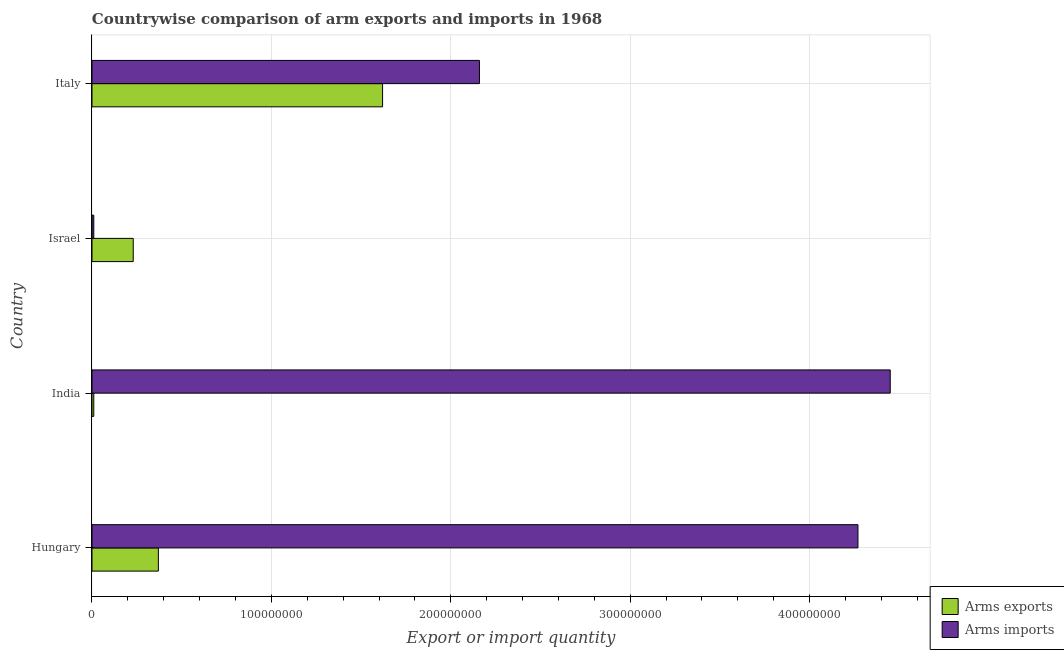How many different coloured bars are there?
Offer a very short reply. 2. How many groups of bars are there?
Offer a terse response. 4. How many bars are there on the 1st tick from the top?
Provide a short and direct response. 2. How many bars are there on the 1st tick from the bottom?
Provide a short and direct response. 2. What is the arms imports in Israel?
Your answer should be very brief. 1.00e+06. Across all countries, what is the maximum arms imports?
Provide a succinct answer. 4.45e+08. Across all countries, what is the minimum arms imports?
Give a very brief answer. 1.00e+06. In which country was the arms exports minimum?
Ensure brevity in your answer.  India. What is the total arms exports in the graph?
Offer a terse response. 2.23e+08. What is the difference between the arms imports in India and that in Italy?
Your answer should be compact. 2.29e+08. What is the difference between the arms exports in Israel and the arms imports in Italy?
Offer a terse response. -1.93e+08. What is the average arms imports per country?
Offer a very short reply. 2.72e+08. What is the difference between the arms exports and arms imports in India?
Your answer should be very brief. -4.44e+08. In how many countries, is the arms exports greater than 300000000 ?
Your response must be concise. 0. What is the ratio of the arms exports in Hungary to that in Italy?
Keep it short and to the point. 0.23. Is the arms exports in India less than that in Israel?
Offer a terse response. Yes. Is the difference between the arms exports in Israel and Italy greater than the difference between the arms imports in Israel and Italy?
Ensure brevity in your answer.  Yes. What is the difference between the highest and the second highest arms imports?
Your answer should be very brief. 1.80e+07. What is the difference between the highest and the lowest arms exports?
Ensure brevity in your answer.  1.61e+08. In how many countries, is the arms imports greater than the average arms imports taken over all countries?
Your answer should be very brief. 2. Is the sum of the arms exports in India and Italy greater than the maximum arms imports across all countries?
Keep it short and to the point. No. What does the 1st bar from the top in Israel represents?
Offer a terse response. Arms imports. What does the 2nd bar from the bottom in Italy represents?
Offer a very short reply. Arms imports. Are all the bars in the graph horizontal?
Your response must be concise. Yes. How many countries are there in the graph?
Your answer should be compact. 4. What is the difference between two consecutive major ticks on the X-axis?
Give a very brief answer. 1.00e+08. Are the values on the major ticks of X-axis written in scientific E-notation?
Provide a succinct answer. No. How many legend labels are there?
Ensure brevity in your answer.  2. What is the title of the graph?
Offer a terse response. Countrywise comparison of arm exports and imports in 1968. Does "Female entrants" appear as one of the legend labels in the graph?
Provide a short and direct response. No. What is the label or title of the X-axis?
Your response must be concise. Export or import quantity. What is the label or title of the Y-axis?
Ensure brevity in your answer.  Country. What is the Export or import quantity of Arms exports in Hungary?
Your response must be concise. 3.70e+07. What is the Export or import quantity in Arms imports in Hungary?
Your response must be concise. 4.27e+08. What is the Export or import quantity in Arms imports in India?
Ensure brevity in your answer.  4.45e+08. What is the Export or import quantity in Arms exports in Israel?
Your answer should be very brief. 2.30e+07. What is the Export or import quantity in Arms imports in Israel?
Your answer should be very brief. 1.00e+06. What is the Export or import quantity in Arms exports in Italy?
Ensure brevity in your answer.  1.62e+08. What is the Export or import quantity of Arms imports in Italy?
Your answer should be very brief. 2.16e+08. Across all countries, what is the maximum Export or import quantity of Arms exports?
Your answer should be compact. 1.62e+08. Across all countries, what is the maximum Export or import quantity of Arms imports?
Keep it short and to the point. 4.45e+08. Across all countries, what is the minimum Export or import quantity in Arms exports?
Offer a very short reply. 1.00e+06. What is the total Export or import quantity of Arms exports in the graph?
Provide a succinct answer. 2.23e+08. What is the total Export or import quantity in Arms imports in the graph?
Ensure brevity in your answer.  1.09e+09. What is the difference between the Export or import quantity in Arms exports in Hungary and that in India?
Your answer should be very brief. 3.60e+07. What is the difference between the Export or import quantity in Arms imports in Hungary and that in India?
Your answer should be compact. -1.80e+07. What is the difference between the Export or import quantity of Arms exports in Hungary and that in Israel?
Provide a succinct answer. 1.40e+07. What is the difference between the Export or import quantity in Arms imports in Hungary and that in Israel?
Ensure brevity in your answer.  4.26e+08. What is the difference between the Export or import quantity of Arms exports in Hungary and that in Italy?
Your response must be concise. -1.25e+08. What is the difference between the Export or import quantity of Arms imports in Hungary and that in Italy?
Offer a terse response. 2.11e+08. What is the difference between the Export or import quantity of Arms exports in India and that in Israel?
Provide a succinct answer. -2.20e+07. What is the difference between the Export or import quantity of Arms imports in India and that in Israel?
Give a very brief answer. 4.44e+08. What is the difference between the Export or import quantity of Arms exports in India and that in Italy?
Offer a terse response. -1.61e+08. What is the difference between the Export or import quantity in Arms imports in India and that in Italy?
Your answer should be compact. 2.29e+08. What is the difference between the Export or import quantity of Arms exports in Israel and that in Italy?
Offer a terse response. -1.39e+08. What is the difference between the Export or import quantity of Arms imports in Israel and that in Italy?
Offer a very short reply. -2.15e+08. What is the difference between the Export or import quantity in Arms exports in Hungary and the Export or import quantity in Arms imports in India?
Your response must be concise. -4.08e+08. What is the difference between the Export or import quantity of Arms exports in Hungary and the Export or import quantity of Arms imports in Israel?
Ensure brevity in your answer.  3.60e+07. What is the difference between the Export or import quantity of Arms exports in Hungary and the Export or import quantity of Arms imports in Italy?
Your answer should be very brief. -1.79e+08. What is the difference between the Export or import quantity of Arms exports in India and the Export or import quantity of Arms imports in Israel?
Keep it short and to the point. 0. What is the difference between the Export or import quantity of Arms exports in India and the Export or import quantity of Arms imports in Italy?
Keep it short and to the point. -2.15e+08. What is the difference between the Export or import quantity of Arms exports in Israel and the Export or import quantity of Arms imports in Italy?
Your answer should be compact. -1.93e+08. What is the average Export or import quantity of Arms exports per country?
Offer a very short reply. 5.58e+07. What is the average Export or import quantity in Arms imports per country?
Your answer should be very brief. 2.72e+08. What is the difference between the Export or import quantity of Arms exports and Export or import quantity of Arms imports in Hungary?
Your response must be concise. -3.90e+08. What is the difference between the Export or import quantity in Arms exports and Export or import quantity in Arms imports in India?
Offer a very short reply. -4.44e+08. What is the difference between the Export or import quantity in Arms exports and Export or import quantity in Arms imports in Israel?
Offer a terse response. 2.20e+07. What is the difference between the Export or import quantity in Arms exports and Export or import quantity in Arms imports in Italy?
Keep it short and to the point. -5.40e+07. What is the ratio of the Export or import quantity in Arms imports in Hungary to that in India?
Keep it short and to the point. 0.96. What is the ratio of the Export or import quantity in Arms exports in Hungary to that in Israel?
Make the answer very short. 1.61. What is the ratio of the Export or import quantity in Arms imports in Hungary to that in Israel?
Ensure brevity in your answer.  427. What is the ratio of the Export or import quantity in Arms exports in Hungary to that in Italy?
Offer a terse response. 0.23. What is the ratio of the Export or import quantity of Arms imports in Hungary to that in Italy?
Your response must be concise. 1.98. What is the ratio of the Export or import quantity in Arms exports in India to that in Israel?
Offer a terse response. 0.04. What is the ratio of the Export or import quantity of Arms imports in India to that in Israel?
Provide a short and direct response. 445. What is the ratio of the Export or import quantity in Arms exports in India to that in Italy?
Give a very brief answer. 0.01. What is the ratio of the Export or import quantity in Arms imports in India to that in Italy?
Offer a very short reply. 2.06. What is the ratio of the Export or import quantity in Arms exports in Israel to that in Italy?
Offer a very short reply. 0.14. What is the ratio of the Export or import quantity in Arms imports in Israel to that in Italy?
Your answer should be very brief. 0. What is the difference between the highest and the second highest Export or import quantity of Arms exports?
Keep it short and to the point. 1.25e+08. What is the difference between the highest and the second highest Export or import quantity of Arms imports?
Your answer should be compact. 1.80e+07. What is the difference between the highest and the lowest Export or import quantity in Arms exports?
Offer a very short reply. 1.61e+08. What is the difference between the highest and the lowest Export or import quantity of Arms imports?
Your response must be concise. 4.44e+08. 